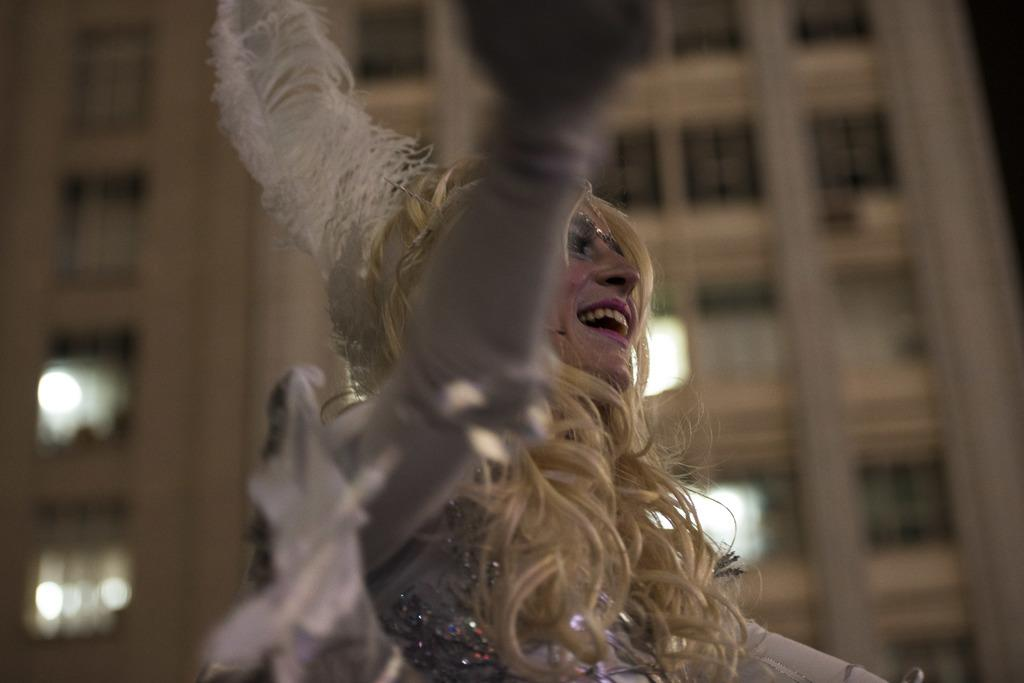What is the main subject of the image? There is a person in the image. Can you describe the person's appearance? The person is wearing clothes. How would you describe the background of the image? The background of the image is slightly blurred. What type of animals can be seen in the zoo in the image? There is no zoo present in the image; it features a person with a blurred background. What is being exchanged between the two people in the image? There are no two people present in the image, only one person wearing clothes. 